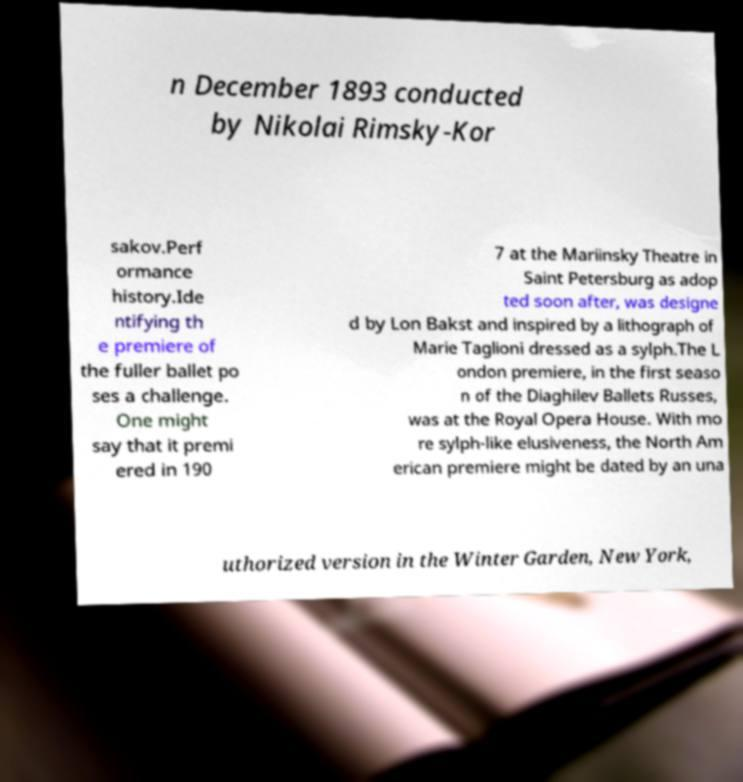What messages or text are displayed in this image? I need them in a readable, typed format. n December 1893 conducted by Nikolai Rimsky-Kor sakov.Perf ormance history.Ide ntifying th e premiere of the fuller ballet po ses a challenge. One might say that it premi ered in 190 7 at the Mariinsky Theatre in Saint Petersburg as adop ted soon after, was designe d by Lon Bakst and inspired by a lithograph of Marie Taglioni dressed as a sylph.The L ondon premiere, in the first seaso n of the Diaghilev Ballets Russes, was at the Royal Opera House. With mo re sylph-like elusiveness, the North Am erican premiere might be dated by an una uthorized version in the Winter Garden, New York, 